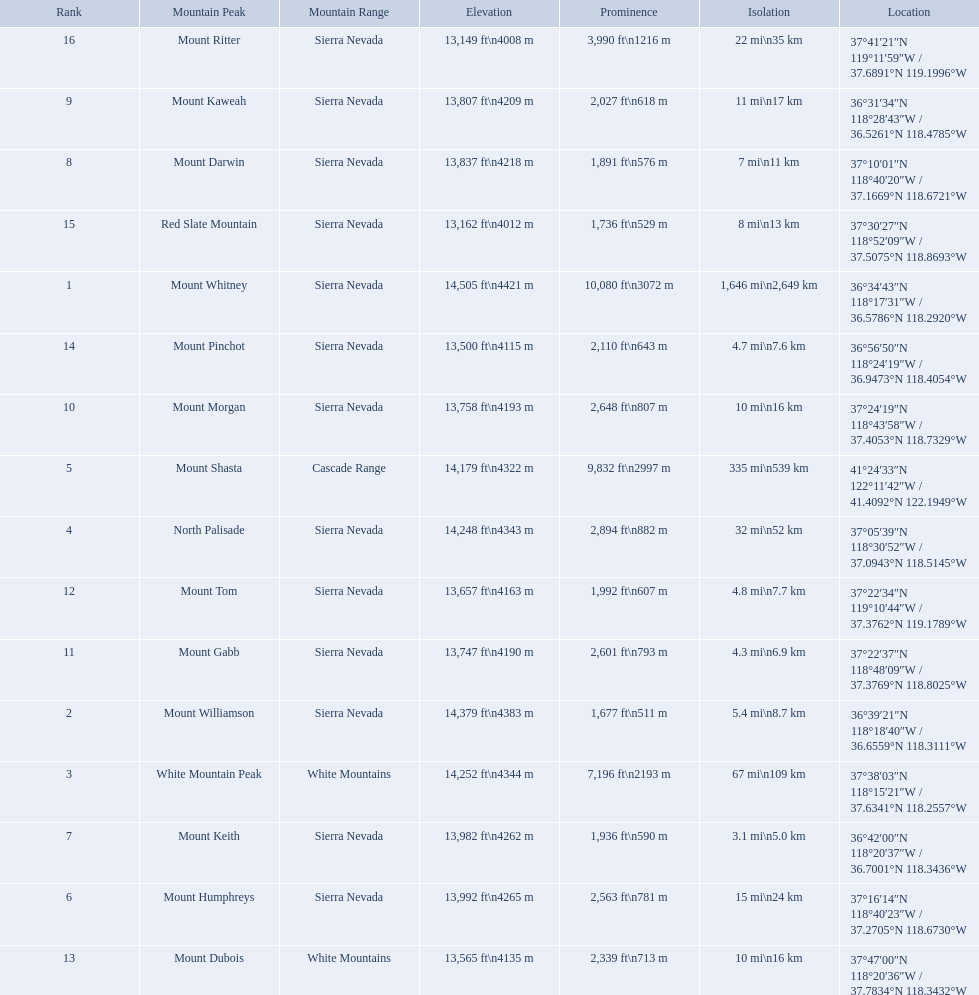What are the peaks in california? Mount Whitney, Mount Williamson, White Mountain Peak, North Palisade, Mount Shasta, Mount Humphreys, Mount Keith, Mount Darwin, Mount Kaweah, Mount Morgan, Mount Gabb, Mount Tom, Mount Dubois, Mount Pinchot, Red Slate Mountain, Mount Ritter. What are the peaks in sierra nevada, california? Mount Whitney, Mount Williamson, North Palisade, Mount Humphreys, Mount Keith, Mount Darwin, Mount Kaweah, Mount Morgan, Mount Gabb, Mount Tom, Mount Pinchot, Red Slate Mountain, Mount Ritter. What are the heights of the peaks in sierra nevada? 14,505 ft\n4421 m, 14,379 ft\n4383 m, 14,248 ft\n4343 m, 13,992 ft\n4265 m, 13,982 ft\n4262 m, 13,837 ft\n4218 m, 13,807 ft\n4209 m, 13,758 ft\n4193 m, 13,747 ft\n4190 m, 13,657 ft\n4163 m, 13,500 ft\n4115 m, 13,162 ft\n4012 m, 13,149 ft\n4008 m. Help me parse the entirety of this table. {'header': ['Rank', 'Mountain Peak', 'Mountain Range', 'Elevation', 'Prominence', 'Isolation', 'Location'], 'rows': [['16', 'Mount Ritter', 'Sierra Nevada', '13,149\xa0ft\\n4008\xa0m', '3,990\xa0ft\\n1216\xa0m', '22\xa0mi\\n35\xa0km', '37°41′21″N 119°11′59″W\ufeff / \ufeff37.6891°N 119.1996°W'], ['9', 'Mount Kaweah', 'Sierra Nevada', '13,807\xa0ft\\n4209\xa0m', '2,027\xa0ft\\n618\xa0m', '11\xa0mi\\n17\xa0km', '36°31′34″N 118°28′43″W\ufeff / \ufeff36.5261°N 118.4785°W'], ['8', 'Mount Darwin', 'Sierra Nevada', '13,837\xa0ft\\n4218\xa0m', '1,891\xa0ft\\n576\xa0m', '7\xa0mi\\n11\xa0km', '37°10′01″N 118°40′20″W\ufeff / \ufeff37.1669°N 118.6721°W'], ['15', 'Red Slate Mountain', 'Sierra Nevada', '13,162\xa0ft\\n4012\xa0m', '1,736\xa0ft\\n529\xa0m', '8\xa0mi\\n13\xa0km', '37°30′27″N 118°52′09″W\ufeff / \ufeff37.5075°N 118.8693°W'], ['1', 'Mount Whitney', 'Sierra Nevada', '14,505\xa0ft\\n4421\xa0m', '10,080\xa0ft\\n3072\xa0m', '1,646\xa0mi\\n2,649\xa0km', '36°34′43″N 118°17′31″W\ufeff / \ufeff36.5786°N 118.2920°W'], ['14', 'Mount Pinchot', 'Sierra Nevada', '13,500\xa0ft\\n4115\xa0m', '2,110\xa0ft\\n643\xa0m', '4.7\xa0mi\\n7.6\xa0km', '36°56′50″N 118°24′19″W\ufeff / \ufeff36.9473°N 118.4054°W'], ['10', 'Mount Morgan', 'Sierra Nevada', '13,758\xa0ft\\n4193\xa0m', '2,648\xa0ft\\n807\xa0m', '10\xa0mi\\n16\xa0km', '37°24′19″N 118°43′58″W\ufeff / \ufeff37.4053°N 118.7329°W'], ['5', 'Mount Shasta', 'Cascade Range', '14,179\xa0ft\\n4322\xa0m', '9,832\xa0ft\\n2997\xa0m', '335\xa0mi\\n539\xa0km', '41°24′33″N 122°11′42″W\ufeff / \ufeff41.4092°N 122.1949°W'], ['4', 'North Palisade', 'Sierra Nevada', '14,248\xa0ft\\n4343\xa0m', '2,894\xa0ft\\n882\xa0m', '32\xa0mi\\n52\xa0km', '37°05′39″N 118°30′52″W\ufeff / \ufeff37.0943°N 118.5145°W'], ['12', 'Mount Tom', 'Sierra Nevada', '13,657\xa0ft\\n4163\xa0m', '1,992\xa0ft\\n607\xa0m', '4.8\xa0mi\\n7.7\xa0km', '37°22′34″N 119°10′44″W\ufeff / \ufeff37.3762°N 119.1789°W'], ['11', 'Mount Gabb', 'Sierra Nevada', '13,747\xa0ft\\n4190\xa0m', '2,601\xa0ft\\n793\xa0m', '4.3\xa0mi\\n6.9\xa0km', '37°22′37″N 118°48′09″W\ufeff / \ufeff37.3769°N 118.8025°W'], ['2', 'Mount Williamson', 'Sierra Nevada', '14,379\xa0ft\\n4383\xa0m', '1,677\xa0ft\\n511\xa0m', '5.4\xa0mi\\n8.7\xa0km', '36°39′21″N 118°18′40″W\ufeff / \ufeff36.6559°N 118.3111°W'], ['3', 'White Mountain Peak', 'White Mountains', '14,252\xa0ft\\n4344\xa0m', '7,196\xa0ft\\n2193\xa0m', '67\xa0mi\\n109\xa0km', '37°38′03″N 118°15′21″W\ufeff / \ufeff37.6341°N 118.2557°W'], ['7', 'Mount Keith', 'Sierra Nevada', '13,982\xa0ft\\n4262\xa0m', '1,936\xa0ft\\n590\xa0m', '3.1\xa0mi\\n5.0\xa0km', '36°42′00″N 118°20′37″W\ufeff / \ufeff36.7001°N 118.3436°W'], ['6', 'Mount Humphreys', 'Sierra Nevada', '13,992\xa0ft\\n4265\xa0m', '2,563\xa0ft\\n781\xa0m', '15\xa0mi\\n24\xa0km', '37°16′14″N 118°40′23″W\ufeff / \ufeff37.2705°N 118.6730°W'], ['13', 'Mount Dubois', 'White Mountains', '13,565\xa0ft\\n4135\xa0m', '2,339\xa0ft\\n713\xa0m', '10\xa0mi\\n16\xa0km', '37°47′00″N 118°20′36″W\ufeff / \ufeff37.7834°N 118.3432°W']]} Which is the highest? Mount Whitney. Which are the mountain peaks? Mount Whitney, Mount Williamson, White Mountain Peak, North Palisade, Mount Shasta, Mount Humphreys, Mount Keith, Mount Darwin, Mount Kaweah, Mount Morgan, Mount Gabb, Mount Tom, Mount Dubois, Mount Pinchot, Red Slate Mountain, Mount Ritter. Of these, which is in the cascade range? Mount Shasta. 